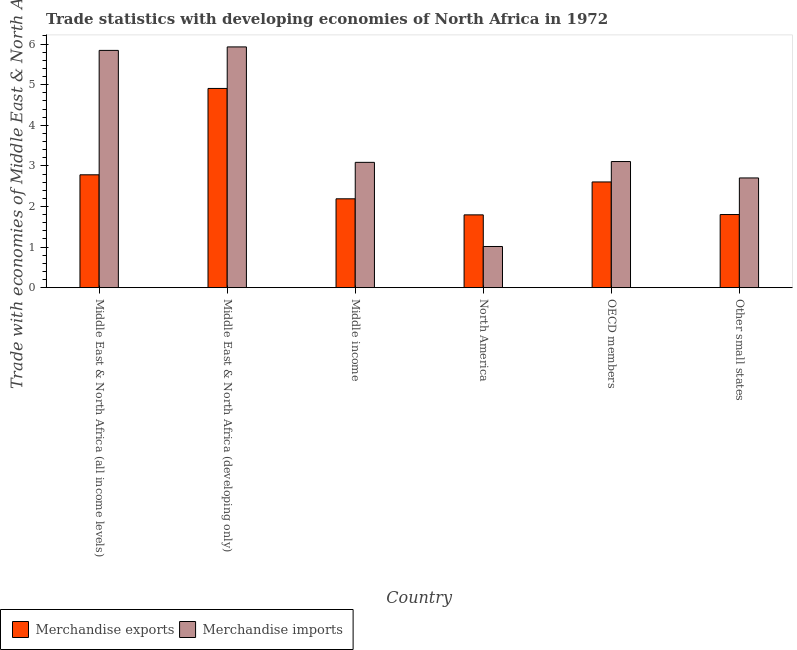How many different coloured bars are there?
Give a very brief answer. 2. How many bars are there on the 5th tick from the right?
Give a very brief answer. 2. What is the merchandise imports in Other small states?
Keep it short and to the point. 2.7. Across all countries, what is the maximum merchandise imports?
Keep it short and to the point. 5.93. Across all countries, what is the minimum merchandise exports?
Ensure brevity in your answer.  1.79. In which country was the merchandise imports maximum?
Provide a succinct answer. Middle East & North Africa (developing only). In which country was the merchandise exports minimum?
Offer a very short reply. North America. What is the total merchandise exports in the graph?
Provide a short and direct response. 16.08. What is the difference between the merchandise exports in Middle East & North Africa (all income levels) and that in Middle East & North Africa (developing only)?
Give a very brief answer. -2.13. What is the difference between the merchandise imports in OECD members and the merchandise exports in North America?
Make the answer very short. 1.31. What is the average merchandise imports per country?
Your answer should be compact. 3.61. What is the difference between the merchandise imports and merchandise exports in Middle East & North Africa (developing only)?
Offer a terse response. 1.02. In how many countries, is the merchandise imports greater than 4.4 %?
Give a very brief answer. 2. What is the ratio of the merchandise imports in OECD members to that in Other small states?
Make the answer very short. 1.15. Is the merchandise imports in Middle East & North Africa (developing only) less than that in Middle income?
Your answer should be compact. No. Is the difference between the merchandise exports in Middle East & North Africa (all income levels) and OECD members greater than the difference between the merchandise imports in Middle East & North Africa (all income levels) and OECD members?
Your answer should be compact. No. What is the difference between the highest and the second highest merchandise imports?
Give a very brief answer. 0.09. What is the difference between the highest and the lowest merchandise exports?
Provide a succinct answer. 3.11. Are all the bars in the graph horizontal?
Offer a terse response. No. How many countries are there in the graph?
Provide a succinct answer. 6. What is the difference between two consecutive major ticks on the Y-axis?
Your answer should be very brief. 1. How are the legend labels stacked?
Offer a terse response. Horizontal. What is the title of the graph?
Give a very brief answer. Trade statistics with developing economies of North Africa in 1972. What is the label or title of the X-axis?
Offer a very short reply. Country. What is the label or title of the Y-axis?
Your answer should be compact. Trade with economies of Middle East & North Africa(%). What is the Trade with economies of Middle East & North Africa(%) of Merchandise exports in Middle East & North Africa (all income levels)?
Give a very brief answer. 2.78. What is the Trade with economies of Middle East & North Africa(%) in Merchandise imports in Middle East & North Africa (all income levels)?
Make the answer very short. 5.84. What is the Trade with economies of Middle East & North Africa(%) in Merchandise exports in Middle East & North Africa (developing only)?
Your response must be concise. 4.91. What is the Trade with economies of Middle East & North Africa(%) in Merchandise imports in Middle East & North Africa (developing only)?
Your answer should be compact. 5.93. What is the Trade with economies of Middle East & North Africa(%) of Merchandise exports in Middle income?
Your answer should be very brief. 2.19. What is the Trade with economies of Middle East & North Africa(%) in Merchandise imports in Middle income?
Give a very brief answer. 3.09. What is the Trade with economies of Middle East & North Africa(%) of Merchandise exports in North America?
Offer a very short reply. 1.79. What is the Trade with economies of Middle East & North Africa(%) in Merchandise imports in North America?
Provide a succinct answer. 1.01. What is the Trade with economies of Middle East & North Africa(%) in Merchandise exports in OECD members?
Make the answer very short. 2.6. What is the Trade with economies of Middle East & North Africa(%) in Merchandise imports in OECD members?
Offer a very short reply. 3.11. What is the Trade with economies of Middle East & North Africa(%) of Merchandise exports in Other small states?
Ensure brevity in your answer.  1.8. What is the Trade with economies of Middle East & North Africa(%) in Merchandise imports in Other small states?
Your response must be concise. 2.7. Across all countries, what is the maximum Trade with economies of Middle East & North Africa(%) in Merchandise exports?
Offer a very short reply. 4.91. Across all countries, what is the maximum Trade with economies of Middle East & North Africa(%) in Merchandise imports?
Keep it short and to the point. 5.93. Across all countries, what is the minimum Trade with economies of Middle East & North Africa(%) in Merchandise exports?
Your answer should be compact. 1.79. Across all countries, what is the minimum Trade with economies of Middle East & North Africa(%) in Merchandise imports?
Make the answer very short. 1.01. What is the total Trade with economies of Middle East & North Africa(%) in Merchandise exports in the graph?
Offer a very short reply. 16.08. What is the total Trade with economies of Middle East & North Africa(%) in Merchandise imports in the graph?
Your response must be concise. 21.69. What is the difference between the Trade with economies of Middle East & North Africa(%) in Merchandise exports in Middle East & North Africa (all income levels) and that in Middle East & North Africa (developing only)?
Your response must be concise. -2.13. What is the difference between the Trade with economies of Middle East & North Africa(%) in Merchandise imports in Middle East & North Africa (all income levels) and that in Middle East & North Africa (developing only)?
Ensure brevity in your answer.  -0.09. What is the difference between the Trade with economies of Middle East & North Africa(%) of Merchandise exports in Middle East & North Africa (all income levels) and that in Middle income?
Your answer should be compact. 0.59. What is the difference between the Trade with economies of Middle East & North Africa(%) in Merchandise imports in Middle East & North Africa (all income levels) and that in Middle income?
Your answer should be compact. 2.76. What is the difference between the Trade with economies of Middle East & North Africa(%) in Merchandise exports in Middle East & North Africa (all income levels) and that in North America?
Give a very brief answer. 0.99. What is the difference between the Trade with economies of Middle East & North Africa(%) of Merchandise imports in Middle East & North Africa (all income levels) and that in North America?
Ensure brevity in your answer.  4.83. What is the difference between the Trade with economies of Middle East & North Africa(%) in Merchandise exports in Middle East & North Africa (all income levels) and that in OECD members?
Your answer should be compact. 0.18. What is the difference between the Trade with economies of Middle East & North Africa(%) in Merchandise imports in Middle East & North Africa (all income levels) and that in OECD members?
Ensure brevity in your answer.  2.74. What is the difference between the Trade with economies of Middle East & North Africa(%) of Merchandise exports in Middle East & North Africa (all income levels) and that in Other small states?
Ensure brevity in your answer.  0.98. What is the difference between the Trade with economies of Middle East & North Africa(%) of Merchandise imports in Middle East & North Africa (all income levels) and that in Other small states?
Your answer should be very brief. 3.14. What is the difference between the Trade with economies of Middle East & North Africa(%) of Merchandise exports in Middle East & North Africa (developing only) and that in Middle income?
Ensure brevity in your answer.  2.72. What is the difference between the Trade with economies of Middle East & North Africa(%) of Merchandise imports in Middle East & North Africa (developing only) and that in Middle income?
Give a very brief answer. 2.84. What is the difference between the Trade with economies of Middle East & North Africa(%) in Merchandise exports in Middle East & North Africa (developing only) and that in North America?
Make the answer very short. 3.11. What is the difference between the Trade with economies of Middle East & North Africa(%) of Merchandise imports in Middle East & North Africa (developing only) and that in North America?
Offer a terse response. 4.92. What is the difference between the Trade with economies of Middle East & North Africa(%) in Merchandise exports in Middle East & North Africa (developing only) and that in OECD members?
Make the answer very short. 2.3. What is the difference between the Trade with economies of Middle East & North Africa(%) in Merchandise imports in Middle East & North Africa (developing only) and that in OECD members?
Provide a short and direct response. 2.82. What is the difference between the Trade with economies of Middle East & North Africa(%) in Merchandise exports in Middle East & North Africa (developing only) and that in Other small states?
Ensure brevity in your answer.  3.11. What is the difference between the Trade with economies of Middle East & North Africa(%) of Merchandise imports in Middle East & North Africa (developing only) and that in Other small states?
Your answer should be compact. 3.23. What is the difference between the Trade with economies of Middle East & North Africa(%) in Merchandise exports in Middle income and that in North America?
Provide a short and direct response. 0.4. What is the difference between the Trade with economies of Middle East & North Africa(%) in Merchandise imports in Middle income and that in North America?
Your answer should be compact. 2.07. What is the difference between the Trade with economies of Middle East & North Africa(%) in Merchandise exports in Middle income and that in OECD members?
Give a very brief answer. -0.42. What is the difference between the Trade with economies of Middle East & North Africa(%) of Merchandise imports in Middle income and that in OECD members?
Ensure brevity in your answer.  -0.02. What is the difference between the Trade with economies of Middle East & North Africa(%) in Merchandise exports in Middle income and that in Other small states?
Ensure brevity in your answer.  0.39. What is the difference between the Trade with economies of Middle East & North Africa(%) of Merchandise imports in Middle income and that in Other small states?
Your response must be concise. 0.38. What is the difference between the Trade with economies of Middle East & North Africa(%) of Merchandise exports in North America and that in OECD members?
Your answer should be compact. -0.81. What is the difference between the Trade with economies of Middle East & North Africa(%) in Merchandise imports in North America and that in OECD members?
Your response must be concise. -2.09. What is the difference between the Trade with economies of Middle East & North Africa(%) of Merchandise exports in North America and that in Other small states?
Offer a terse response. -0.01. What is the difference between the Trade with economies of Middle East & North Africa(%) in Merchandise imports in North America and that in Other small states?
Offer a terse response. -1.69. What is the difference between the Trade with economies of Middle East & North Africa(%) in Merchandise exports in OECD members and that in Other small states?
Your response must be concise. 0.8. What is the difference between the Trade with economies of Middle East & North Africa(%) of Merchandise imports in OECD members and that in Other small states?
Provide a short and direct response. 0.4. What is the difference between the Trade with economies of Middle East & North Africa(%) in Merchandise exports in Middle East & North Africa (all income levels) and the Trade with economies of Middle East & North Africa(%) in Merchandise imports in Middle East & North Africa (developing only)?
Offer a terse response. -3.15. What is the difference between the Trade with economies of Middle East & North Africa(%) in Merchandise exports in Middle East & North Africa (all income levels) and the Trade with economies of Middle East & North Africa(%) in Merchandise imports in Middle income?
Ensure brevity in your answer.  -0.31. What is the difference between the Trade with economies of Middle East & North Africa(%) in Merchandise exports in Middle East & North Africa (all income levels) and the Trade with economies of Middle East & North Africa(%) in Merchandise imports in North America?
Make the answer very short. 1.77. What is the difference between the Trade with economies of Middle East & North Africa(%) in Merchandise exports in Middle East & North Africa (all income levels) and the Trade with economies of Middle East & North Africa(%) in Merchandise imports in OECD members?
Make the answer very short. -0.33. What is the difference between the Trade with economies of Middle East & North Africa(%) of Merchandise exports in Middle East & North Africa (all income levels) and the Trade with economies of Middle East & North Africa(%) of Merchandise imports in Other small states?
Provide a succinct answer. 0.08. What is the difference between the Trade with economies of Middle East & North Africa(%) of Merchandise exports in Middle East & North Africa (developing only) and the Trade with economies of Middle East & North Africa(%) of Merchandise imports in Middle income?
Provide a succinct answer. 1.82. What is the difference between the Trade with economies of Middle East & North Africa(%) in Merchandise exports in Middle East & North Africa (developing only) and the Trade with economies of Middle East & North Africa(%) in Merchandise imports in North America?
Offer a terse response. 3.89. What is the difference between the Trade with economies of Middle East & North Africa(%) of Merchandise exports in Middle East & North Africa (developing only) and the Trade with economies of Middle East & North Africa(%) of Merchandise imports in OECD members?
Your answer should be very brief. 1.8. What is the difference between the Trade with economies of Middle East & North Africa(%) in Merchandise exports in Middle East & North Africa (developing only) and the Trade with economies of Middle East & North Africa(%) in Merchandise imports in Other small states?
Your answer should be very brief. 2.2. What is the difference between the Trade with economies of Middle East & North Africa(%) in Merchandise exports in Middle income and the Trade with economies of Middle East & North Africa(%) in Merchandise imports in North America?
Make the answer very short. 1.17. What is the difference between the Trade with economies of Middle East & North Africa(%) of Merchandise exports in Middle income and the Trade with economies of Middle East & North Africa(%) of Merchandise imports in OECD members?
Provide a succinct answer. -0.92. What is the difference between the Trade with economies of Middle East & North Africa(%) in Merchandise exports in Middle income and the Trade with economies of Middle East & North Africa(%) in Merchandise imports in Other small states?
Provide a succinct answer. -0.51. What is the difference between the Trade with economies of Middle East & North Africa(%) of Merchandise exports in North America and the Trade with economies of Middle East & North Africa(%) of Merchandise imports in OECD members?
Give a very brief answer. -1.31. What is the difference between the Trade with economies of Middle East & North Africa(%) in Merchandise exports in North America and the Trade with economies of Middle East & North Africa(%) in Merchandise imports in Other small states?
Offer a terse response. -0.91. What is the difference between the Trade with economies of Middle East & North Africa(%) of Merchandise exports in OECD members and the Trade with economies of Middle East & North Africa(%) of Merchandise imports in Other small states?
Make the answer very short. -0.1. What is the average Trade with economies of Middle East & North Africa(%) of Merchandise exports per country?
Offer a terse response. 2.68. What is the average Trade with economies of Middle East & North Africa(%) in Merchandise imports per country?
Your answer should be very brief. 3.61. What is the difference between the Trade with economies of Middle East & North Africa(%) of Merchandise exports and Trade with economies of Middle East & North Africa(%) of Merchandise imports in Middle East & North Africa (all income levels)?
Provide a short and direct response. -3.06. What is the difference between the Trade with economies of Middle East & North Africa(%) in Merchandise exports and Trade with economies of Middle East & North Africa(%) in Merchandise imports in Middle East & North Africa (developing only)?
Your answer should be very brief. -1.02. What is the difference between the Trade with economies of Middle East & North Africa(%) of Merchandise exports and Trade with economies of Middle East & North Africa(%) of Merchandise imports in Middle income?
Offer a very short reply. -0.9. What is the difference between the Trade with economies of Middle East & North Africa(%) in Merchandise exports and Trade with economies of Middle East & North Africa(%) in Merchandise imports in North America?
Give a very brief answer. 0.78. What is the difference between the Trade with economies of Middle East & North Africa(%) in Merchandise exports and Trade with economies of Middle East & North Africa(%) in Merchandise imports in OECD members?
Make the answer very short. -0.5. What is the difference between the Trade with economies of Middle East & North Africa(%) of Merchandise exports and Trade with economies of Middle East & North Africa(%) of Merchandise imports in Other small states?
Your answer should be very brief. -0.9. What is the ratio of the Trade with economies of Middle East & North Africa(%) in Merchandise exports in Middle East & North Africa (all income levels) to that in Middle East & North Africa (developing only)?
Make the answer very short. 0.57. What is the ratio of the Trade with economies of Middle East & North Africa(%) of Merchandise imports in Middle East & North Africa (all income levels) to that in Middle East & North Africa (developing only)?
Offer a very short reply. 0.99. What is the ratio of the Trade with economies of Middle East & North Africa(%) in Merchandise exports in Middle East & North Africa (all income levels) to that in Middle income?
Ensure brevity in your answer.  1.27. What is the ratio of the Trade with economies of Middle East & North Africa(%) of Merchandise imports in Middle East & North Africa (all income levels) to that in Middle income?
Your answer should be compact. 1.89. What is the ratio of the Trade with economies of Middle East & North Africa(%) in Merchandise exports in Middle East & North Africa (all income levels) to that in North America?
Offer a terse response. 1.55. What is the ratio of the Trade with economies of Middle East & North Africa(%) in Merchandise imports in Middle East & North Africa (all income levels) to that in North America?
Ensure brevity in your answer.  5.76. What is the ratio of the Trade with economies of Middle East & North Africa(%) of Merchandise exports in Middle East & North Africa (all income levels) to that in OECD members?
Your response must be concise. 1.07. What is the ratio of the Trade with economies of Middle East & North Africa(%) of Merchandise imports in Middle East & North Africa (all income levels) to that in OECD members?
Your answer should be very brief. 1.88. What is the ratio of the Trade with economies of Middle East & North Africa(%) in Merchandise exports in Middle East & North Africa (all income levels) to that in Other small states?
Your response must be concise. 1.54. What is the ratio of the Trade with economies of Middle East & North Africa(%) in Merchandise imports in Middle East & North Africa (all income levels) to that in Other small states?
Provide a succinct answer. 2.16. What is the ratio of the Trade with economies of Middle East & North Africa(%) of Merchandise exports in Middle East & North Africa (developing only) to that in Middle income?
Provide a short and direct response. 2.24. What is the ratio of the Trade with economies of Middle East & North Africa(%) of Merchandise imports in Middle East & North Africa (developing only) to that in Middle income?
Give a very brief answer. 1.92. What is the ratio of the Trade with economies of Middle East & North Africa(%) of Merchandise exports in Middle East & North Africa (developing only) to that in North America?
Keep it short and to the point. 2.74. What is the ratio of the Trade with economies of Middle East & North Africa(%) in Merchandise imports in Middle East & North Africa (developing only) to that in North America?
Ensure brevity in your answer.  5.85. What is the ratio of the Trade with economies of Middle East & North Africa(%) of Merchandise exports in Middle East & North Africa (developing only) to that in OECD members?
Provide a short and direct response. 1.88. What is the ratio of the Trade with economies of Middle East & North Africa(%) in Merchandise imports in Middle East & North Africa (developing only) to that in OECD members?
Ensure brevity in your answer.  1.91. What is the ratio of the Trade with economies of Middle East & North Africa(%) in Merchandise exports in Middle East & North Africa (developing only) to that in Other small states?
Provide a succinct answer. 2.72. What is the ratio of the Trade with economies of Middle East & North Africa(%) in Merchandise imports in Middle East & North Africa (developing only) to that in Other small states?
Give a very brief answer. 2.19. What is the ratio of the Trade with economies of Middle East & North Africa(%) of Merchandise exports in Middle income to that in North America?
Your answer should be very brief. 1.22. What is the ratio of the Trade with economies of Middle East & North Africa(%) in Merchandise imports in Middle income to that in North America?
Your response must be concise. 3.04. What is the ratio of the Trade with economies of Middle East & North Africa(%) in Merchandise exports in Middle income to that in OECD members?
Your answer should be compact. 0.84. What is the ratio of the Trade with economies of Middle East & North Africa(%) of Merchandise imports in Middle income to that in OECD members?
Your answer should be very brief. 0.99. What is the ratio of the Trade with economies of Middle East & North Africa(%) of Merchandise exports in Middle income to that in Other small states?
Your answer should be compact. 1.22. What is the ratio of the Trade with economies of Middle East & North Africa(%) of Merchandise imports in Middle income to that in Other small states?
Make the answer very short. 1.14. What is the ratio of the Trade with economies of Middle East & North Africa(%) in Merchandise exports in North America to that in OECD members?
Provide a short and direct response. 0.69. What is the ratio of the Trade with economies of Middle East & North Africa(%) of Merchandise imports in North America to that in OECD members?
Your answer should be very brief. 0.33. What is the ratio of the Trade with economies of Middle East & North Africa(%) of Merchandise exports in North America to that in Other small states?
Your response must be concise. 1. What is the ratio of the Trade with economies of Middle East & North Africa(%) in Merchandise imports in North America to that in Other small states?
Provide a short and direct response. 0.38. What is the ratio of the Trade with economies of Middle East & North Africa(%) in Merchandise exports in OECD members to that in Other small states?
Ensure brevity in your answer.  1.45. What is the ratio of the Trade with economies of Middle East & North Africa(%) in Merchandise imports in OECD members to that in Other small states?
Offer a terse response. 1.15. What is the difference between the highest and the second highest Trade with economies of Middle East & North Africa(%) of Merchandise exports?
Make the answer very short. 2.13. What is the difference between the highest and the second highest Trade with economies of Middle East & North Africa(%) of Merchandise imports?
Give a very brief answer. 0.09. What is the difference between the highest and the lowest Trade with economies of Middle East & North Africa(%) in Merchandise exports?
Make the answer very short. 3.11. What is the difference between the highest and the lowest Trade with economies of Middle East & North Africa(%) in Merchandise imports?
Your answer should be very brief. 4.92. 